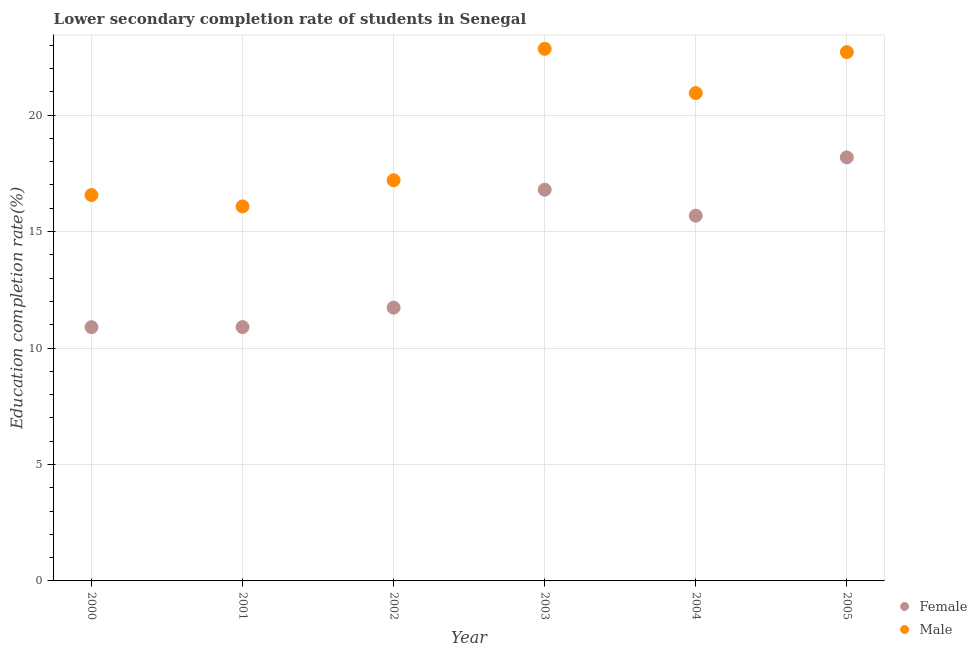How many different coloured dotlines are there?
Provide a succinct answer. 2. Is the number of dotlines equal to the number of legend labels?
Your response must be concise. Yes. What is the education completion rate of female students in 2001?
Provide a short and direct response. 10.9. Across all years, what is the maximum education completion rate of male students?
Make the answer very short. 22.85. Across all years, what is the minimum education completion rate of male students?
Offer a very short reply. 16.08. In which year was the education completion rate of male students minimum?
Keep it short and to the point. 2001. What is the total education completion rate of male students in the graph?
Ensure brevity in your answer.  116.35. What is the difference between the education completion rate of male students in 2004 and that in 2005?
Give a very brief answer. -1.76. What is the difference between the education completion rate of female students in 2004 and the education completion rate of male students in 2005?
Offer a terse response. -7.02. What is the average education completion rate of male students per year?
Provide a short and direct response. 19.39. In the year 2000, what is the difference between the education completion rate of female students and education completion rate of male students?
Your answer should be very brief. -5.67. What is the ratio of the education completion rate of female students in 2001 to that in 2003?
Offer a very short reply. 0.65. Is the education completion rate of male students in 2002 less than that in 2003?
Make the answer very short. Yes. Is the difference between the education completion rate of female students in 2001 and 2005 greater than the difference between the education completion rate of male students in 2001 and 2005?
Ensure brevity in your answer.  No. What is the difference between the highest and the second highest education completion rate of female students?
Offer a very short reply. 1.39. What is the difference between the highest and the lowest education completion rate of female students?
Your answer should be very brief. 7.29. In how many years, is the education completion rate of female students greater than the average education completion rate of female students taken over all years?
Make the answer very short. 3. Is the sum of the education completion rate of female students in 2002 and 2004 greater than the maximum education completion rate of male students across all years?
Your answer should be very brief. Yes. Is the education completion rate of male students strictly greater than the education completion rate of female students over the years?
Keep it short and to the point. Yes. How many dotlines are there?
Offer a terse response. 2. Does the graph contain grids?
Keep it short and to the point. Yes. Where does the legend appear in the graph?
Your answer should be compact. Bottom right. How many legend labels are there?
Keep it short and to the point. 2. What is the title of the graph?
Ensure brevity in your answer.  Lower secondary completion rate of students in Senegal. Does "Constant 2005 US$" appear as one of the legend labels in the graph?
Keep it short and to the point. No. What is the label or title of the X-axis?
Offer a very short reply. Year. What is the label or title of the Y-axis?
Ensure brevity in your answer.  Education completion rate(%). What is the Education completion rate(%) of Female in 2000?
Give a very brief answer. 10.9. What is the Education completion rate(%) of Male in 2000?
Your answer should be compact. 16.57. What is the Education completion rate(%) of Female in 2001?
Ensure brevity in your answer.  10.9. What is the Education completion rate(%) of Male in 2001?
Your answer should be compact. 16.08. What is the Education completion rate(%) of Female in 2002?
Ensure brevity in your answer.  11.73. What is the Education completion rate(%) of Male in 2002?
Keep it short and to the point. 17.2. What is the Education completion rate(%) in Female in 2003?
Your answer should be very brief. 16.8. What is the Education completion rate(%) in Male in 2003?
Offer a terse response. 22.85. What is the Education completion rate(%) of Female in 2004?
Give a very brief answer. 15.68. What is the Education completion rate(%) of Male in 2004?
Offer a very short reply. 20.95. What is the Education completion rate(%) in Female in 2005?
Give a very brief answer. 18.18. What is the Education completion rate(%) of Male in 2005?
Give a very brief answer. 22.7. Across all years, what is the maximum Education completion rate(%) of Female?
Give a very brief answer. 18.18. Across all years, what is the maximum Education completion rate(%) in Male?
Provide a short and direct response. 22.85. Across all years, what is the minimum Education completion rate(%) in Female?
Your answer should be very brief. 10.9. Across all years, what is the minimum Education completion rate(%) of Male?
Your response must be concise. 16.08. What is the total Education completion rate(%) of Female in the graph?
Offer a terse response. 84.19. What is the total Education completion rate(%) of Male in the graph?
Provide a short and direct response. 116.35. What is the difference between the Education completion rate(%) in Female in 2000 and that in 2001?
Offer a very short reply. -0. What is the difference between the Education completion rate(%) in Male in 2000 and that in 2001?
Offer a terse response. 0.49. What is the difference between the Education completion rate(%) of Female in 2000 and that in 2002?
Provide a succinct answer. -0.84. What is the difference between the Education completion rate(%) in Male in 2000 and that in 2002?
Provide a short and direct response. -0.64. What is the difference between the Education completion rate(%) in Female in 2000 and that in 2003?
Offer a terse response. -5.9. What is the difference between the Education completion rate(%) in Male in 2000 and that in 2003?
Your response must be concise. -6.28. What is the difference between the Education completion rate(%) of Female in 2000 and that in 2004?
Your answer should be very brief. -4.79. What is the difference between the Education completion rate(%) of Male in 2000 and that in 2004?
Provide a succinct answer. -4.38. What is the difference between the Education completion rate(%) in Female in 2000 and that in 2005?
Ensure brevity in your answer.  -7.29. What is the difference between the Education completion rate(%) of Male in 2000 and that in 2005?
Provide a short and direct response. -6.14. What is the difference between the Education completion rate(%) of Female in 2001 and that in 2002?
Give a very brief answer. -0.84. What is the difference between the Education completion rate(%) of Male in 2001 and that in 2002?
Give a very brief answer. -1.12. What is the difference between the Education completion rate(%) of Female in 2001 and that in 2003?
Offer a very short reply. -5.9. What is the difference between the Education completion rate(%) in Male in 2001 and that in 2003?
Keep it short and to the point. -6.77. What is the difference between the Education completion rate(%) of Female in 2001 and that in 2004?
Provide a succinct answer. -4.78. What is the difference between the Education completion rate(%) of Male in 2001 and that in 2004?
Offer a terse response. -4.87. What is the difference between the Education completion rate(%) in Female in 2001 and that in 2005?
Give a very brief answer. -7.29. What is the difference between the Education completion rate(%) of Male in 2001 and that in 2005?
Ensure brevity in your answer.  -6.62. What is the difference between the Education completion rate(%) in Female in 2002 and that in 2003?
Give a very brief answer. -5.06. What is the difference between the Education completion rate(%) in Male in 2002 and that in 2003?
Ensure brevity in your answer.  -5.64. What is the difference between the Education completion rate(%) in Female in 2002 and that in 2004?
Your answer should be compact. -3.95. What is the difference between the Education completion rate(%) in Male in 2002 and that in 2004?
Make the answer very short. -3.74. What is the difference between the Education completion rate(%) in Female in 2002 and that in 2005?
Ensure brevity in your answer.  -6.45. What is the difference between the Education completion rate(%) in Male in 2002 and that in 2005?
Provide a short and direct response. -5.5. What is the difference between the Education completion rate(%) in Female in 2003 and that in 2004?
Your answer should be compact. 1.12. What is the difference between the Education completion rate(%) of Male in 2003 and that in 2004?
Provide a short and direct response. 1.9. What is the difference between the Education completion rate(%) in Female in 2003 and that in 2005?
Give a very brief answer. -1.39. What is the difference between the Education completion rate(%) of Male in 2003 and that in 2005?
Keep it short and to the point. 0.14. What is the difference between the Education completion rate(%) of Female in 2004 and that in 2005?
Ensure brevity in your answer.  -2.5. What is the difference between the Education completion rate(%) of Male in 2004 and that in 2005?
Your answer should be compact. -1.76. What is the difference between the Education completion rate(%) of Female in 2000 and the Education completion rate(%) of Male in 2001?
Offer a very short reply. -5.18. What is the difference between the Education completion rate(%) in Female in 2000 and the Education completion rate(%) in Male in 2002?
Your answer should be very brief. -6.31. What is the difference between the Education completion rate(%) of Female in 2000 and the Education completion rate(%) of Male in 2003?
Your answer should be compact. -11.95. What is the difference between the Education completion rate(%) in Female in 2000 and the Education completion rate(%) in Male in 2004?
Your answer should be compact. -10.05. What is the difference between the Education completion rate(%) of Female in 2000 and the Education completion rate(%) of Male in 2005?
Your response must be concise. -11.81. What is the difference between the Education completion rate(%) in Female in 2001 and the Education completion rate(%) in Male in 2002?
Offer a very short reply. -6.31. What is the difference between the Education completion rate(%) of Female in 2001 and the Education completion rate(%) of Male in 2003?
Offer a very short reply. -11.95. What is the difference between the Education completion rate(%) of Female in 2001 and the Education completion rate(%) of Male in 2004?
Give a very brief answer. -10.05. What is the difference between the Education completion rate(%) of Female in 2001 and the Education completion rate(%) of Male in 2005?
Give a very brief answer. -11.81. What is the difference between the Education completion rate(%) in Female in 2002 and the Education completion rate(%) in Male in 2003?
Your answer should be compact. -11.11. What is the difference between the Education completion rate(%) of Female in 2002 and the Education completion rate(%) of Male in 2004?
Your answer should be very brief. -9.21. What is the difference between the Education completion rate(%) in Female in 2002 and the Education completion rate(%) in Male in 2005?
Your response must be concise. -10.97. What is the difference between the Education completion rate(%) of Female in 2003 and the Education completion rate(%) of Male in 2004?
Provide a short and direct response. -4.15. What is the difference between the Education completion rate(%) in Female in 2003 and the Education completion rate(%) in Male in 2005?
Ensure brevity in your answer.  -5.91. What is the difference between the Education completion rate(%) in Female in 2004 and the Education completion rate(%) in Male in 2005?
Give a very brief answer. -7.02. What is the average Education completion rate(%) of Female per year?
Ensure brevity in your answer.  14.03. What is the average Education completion rate(%) in Male per year?
Offer a very short reply. 19.39. In the year 2000, what is the difference between the Education completion rate(%) of Female and Education completion rate(%) of Male?
Your answer should be very brief. -5.67. In the year 2001, what is the difference between the Education completion rate(%) in Female and Education completion rate(%) in Male?
Offer a terse response. -5.18. In the year 2002, what is the difference between the Education completion rate(%) of Female and Education completion rate(%) of Male?
Make the answer very short. -5.47. In the year 2003, what is the difference between the Education completion rate(%) of Female and Education completion rate(%) of Male?
Provide a succinct answer. -6.05. In the year 2004, what is the difference between the Education completion rate(%) in Female and Education completion rate(%) in Male?
Offer a very short reply. -5.26. In the year 2005, what is the difference between the Education completion rate(%) of Female and Education completion rate(%) of Male?
Offer a terse response. -4.52. What is the ratio of the Education completion rate(%) in Male in 2000 to that in 2001?
Your answer should be very brief. 1.03. What is the ratio of the Education completion rate(%) of Female in 2000 to that in 2002?
Provide a succinct answer. 0.93. What is the ratio of the Education completion rate(%) of Female in 2000 to that in 2003?
Your response must be concise. 0.65. What is the ratio of the Education completion rate(%) of Male in 2000 to that in 2003?
Give a very brief answer. 0.73. What is the ratio of the Education completion rate(%) in Female in 2000 to that in 2004?
Provide a short and direct response. 0.69. What is the ratio of the Education completion rate(%) in Male in 2000 to that in 2004?
Give a very brief answer. 0.79. What is the ratio of the Education completion rate(%) of Female in 2000 to that in 2005?
Your answer should be compact. 0.6. What is the ratio of the Education completion rate(%) of Male in 2000 to that in 2005?
Provide a succinct answer. 0.73. What is the ratio of the Education completion rate(%) in Female in 2001 to that in 2002?
Offer a terse response. 0.93. What is the ratio of the Education completion rate(%) of Male in 2001 to that in 2002?
Ensure brevity in your answer.  0.93. What is the ratio of the Education completion rate(%) of Female in 2001 to that in 2003?
Make the answer very short. 0.65. What is the ratio of the Education completion rate(%) of Male in 2001 to that in 2003?
Your answer should be very brief. 0.7. What is the ratio of the Education completion rate(%) in Female in 2001 to that in 2004?
Make the answer very short. 0.69. What is the ratio of the Education completion rate(%) in Male in 2001 to that in 2004?
Your answer should be very brief. 0.77. What is the ratio of the Education completion rate(%) of Female in 2001 to that in 2005?
Give a very brief answer. 0.6. What is the ratio of the Education completion rate(%) of Male in 2001 to that in 2005?
Your answer should be compact. 0.71. What is the ratio of the Education completion rate(%) in Female in 2002 to that in 2003?
Provide a succinct answer. 0.7. What is the ratio of the Education completion rate(%) of Male in 2002 to that in 2003?
Ensure brevity in your answer.  0.75. What is the ratio of the Education completion rate(%) in Female in 2002 to that in 2004?
Your answer should be very brief. 0.75. What is the ratio of the Education completion rate(%) in Male in 2002 to that in 2004?
Ensure brevity in your answer.  0.82. What is the ratio of the Education completion rate(%) in Female in 2002 to that in 2005?
Offer a very short reply. 0.65. What is the ratio of the Education completion rate(%) of Male in 2002 to that in 2005?
Your answer should be very brief. 0.76. What is the ratio of the Education completion rate(%) in Female in 2003 to that in 2004?
Keep it short and to the point. 1.07. What is the ratio of the Education completion rate(%) in Male in 2003 to that in 2004?
Provide a short and direct response. 1.09. What is the ratio of the Education completion rate(%) of Female in 2003 to that in 2005?
Provide a short and direct response. 0.92. What is the ratio of the Education completion rate(%) of Male in 2003 to that in 2005?
Provide a succinct answer. 1.01. What is the ratio of the Education completion rate(%) of Female in 2004 to that in 2005?
Ensure brevity in your answer.  0.86. What is the ratio of the Education completion rate(%) in Male in 2004 to that in 2005?
Give a very brief answer. 0.92. What is the difference between the highest and the second highest Education completion rate(%) in Female?
Your answer should be very brief. 1.39. What is the difference between the highest and the second highest Education completion rate(%) of Male?
Make the answer very short. 0.14. What is the difference between the highest and the lowest Education completion rate(%) of Female?
Your answer should be very brief. 7.29. What is the difference between the highest and the lowest Education completion rate(%) of Male?
Keep it short and to the point. 6.77. 